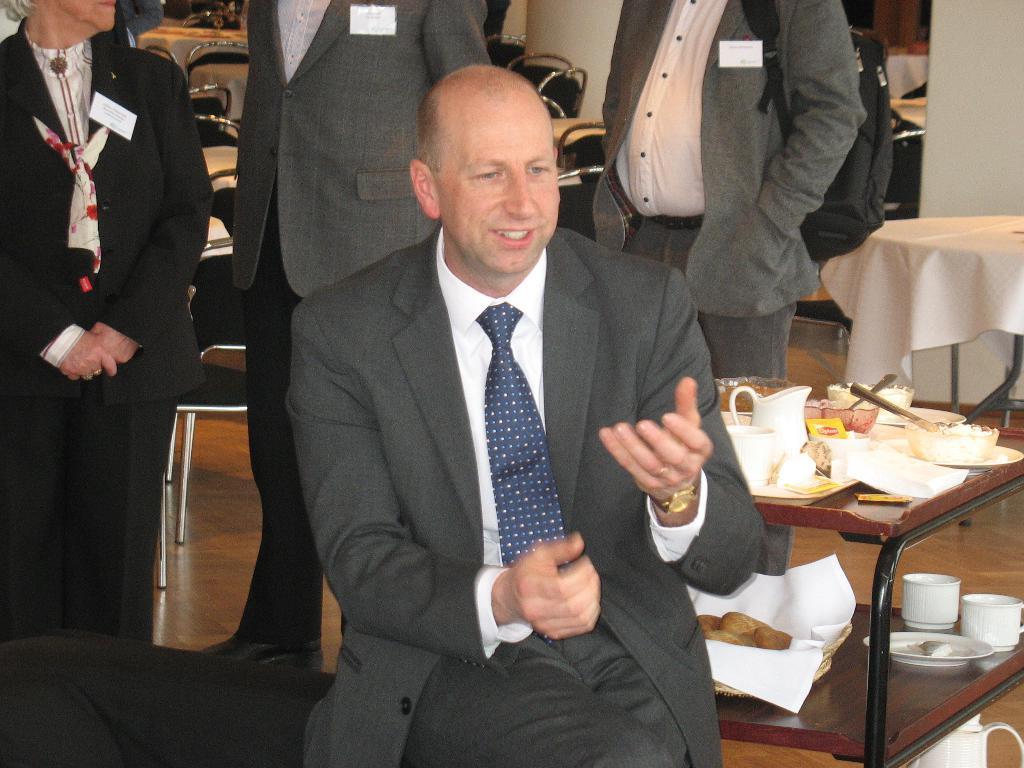Could you give a brief overview of what you see in this image? In the image we can see a person sitting and there are other person standing back of him. There is a table and a chair. On a table a water jar, bowl, spoons are placed. 